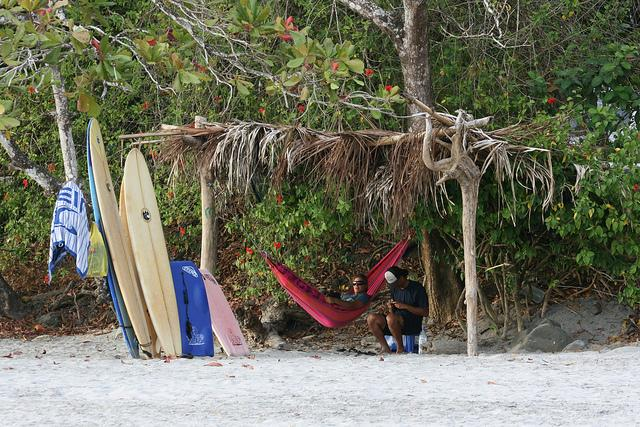What is the person sitting near? Please explain your reasoning. surfboards. There are surfboards stacked up as if for rent. 